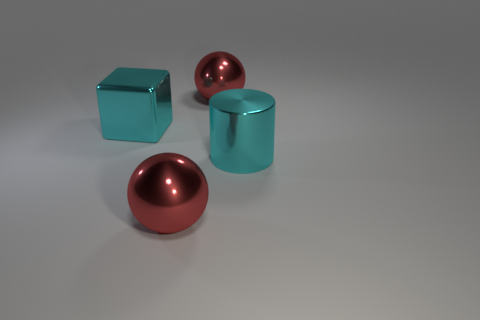The cyan metallic thing that is the same size as the shiny cylinder is what shape?
Provide a succinct answer. Cube. How many other metal blocks have the same color as the large shiny cube?
Offer a very short reply. 0. There is a red shiny object that is behind the big block; what size is it?
Give a very brief answer. Large. How many cyan shiny cylinders are the same size as the cyan metallic block?
Offer a very short reply. 1. There is a large block that is the same material as the large cylinder; what color is it?
Ensure brevity in your answer.  Cyan. Are there fewer large spheres behind the big cyan metallic cylinder than red spheres?
Your answer should be very brief. Yes. What shape is the cyan thing that is made of the same material as the big block?
Provide a succinct answer. Cylinder. What number of metallic things are tiny red cylinders or cubes?
Give a very brief answer. 1. Are there the same number of big metal things that are behind the big cyan cylinder and large cyan cubes?
Give a very brief answer. No. Does the metallic object in front of the large cyan shiny cylinder have the same color as the big metallic cylinder?
Provide a short and direct response. No. 